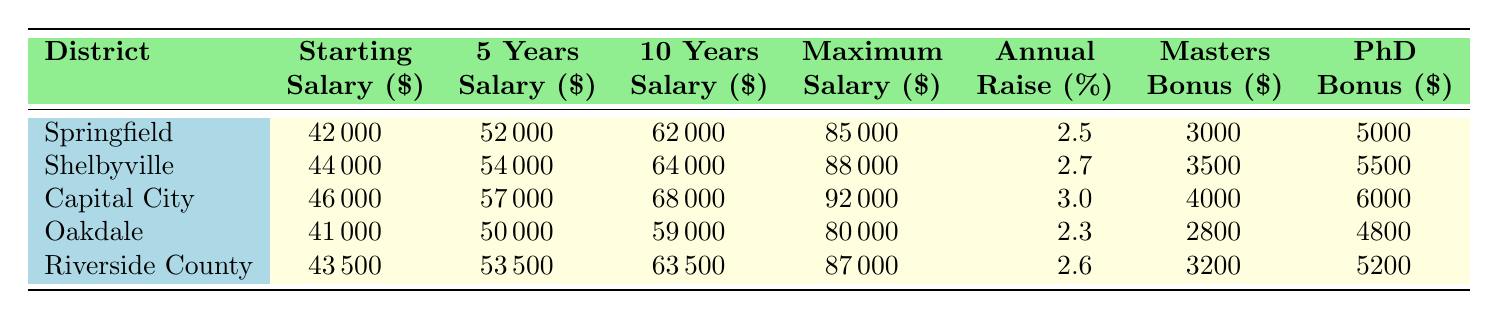What is the starting salary in Capital City Schools? The table lists a specific salary for each district. For Capital City Schools, the starting salary is clearly stated as 46000.
Answer: 46000 Which district has the highest maximum salary? Looking at the maximum salary column in the table, Capital City Schools shows the highest value listed at 92000.
Answer: Capital City Schools What is the average starting salary across all districts? To find the average, I will sum the starting salaries: 42000 + 44000 + 46000 + 41000 + 43500 = 216500. Then, I divide by the number of districts (5): 216500 / 5 = 43300.
Answer: 43300 Is the annual raise percentage in Oakdale School District higher than that in Springfield School District? By comparing the annual raise percentage values in the table, Oakdale has 2.3 percent while Springfield has 2.5 percent, meaning Oakdale's percentage is lower.
Answer: No What is the difference in maximum salary between Shelbyville and Riverside County? I find the maximum salary for Shelbyville, which is 88000, and Riverside County, which is 87000. The difference is 88000 - 87000 = 1000.
Answer: 1000 Which district provides the highest master's degree bonus? The master's degree bonuses for each district can be found in the table. Capital City Schools offers the highest at 4000.
Answer: Capital City Schools After 10 years, which district offers the lowest salary? The 10-year salaries listed are 62000 for Springfield, 64000 for Shelbyville, 68000 for Capital City, 59000 for Oakdale, and 63500 for Riverside County. Oakdale has the lowest at 59000.
Answer: Oakdale If a teacher has a PhD in Shelbyville, what is their total salary after 10 years? The 10-year salary for Shelbyville is 64000, and adding the PhD bonus of 5500 gives a total of 64000 + 5500 = 69500.
Answer: 69500 What percentage difference in annual raise is there between Capital City Schools and Oakdale? Capital City Schools has an annual raise percentage of 3.0, while Oakdale has 2.3. The difference is 3.0 - 2.3 = 0.7. To get the percentage difference, I divide by Oakdale's percentage: (0.7 / 2.3) * 100 ≈ 30.43 percent.
Answer: Approximately 30.43 percent 